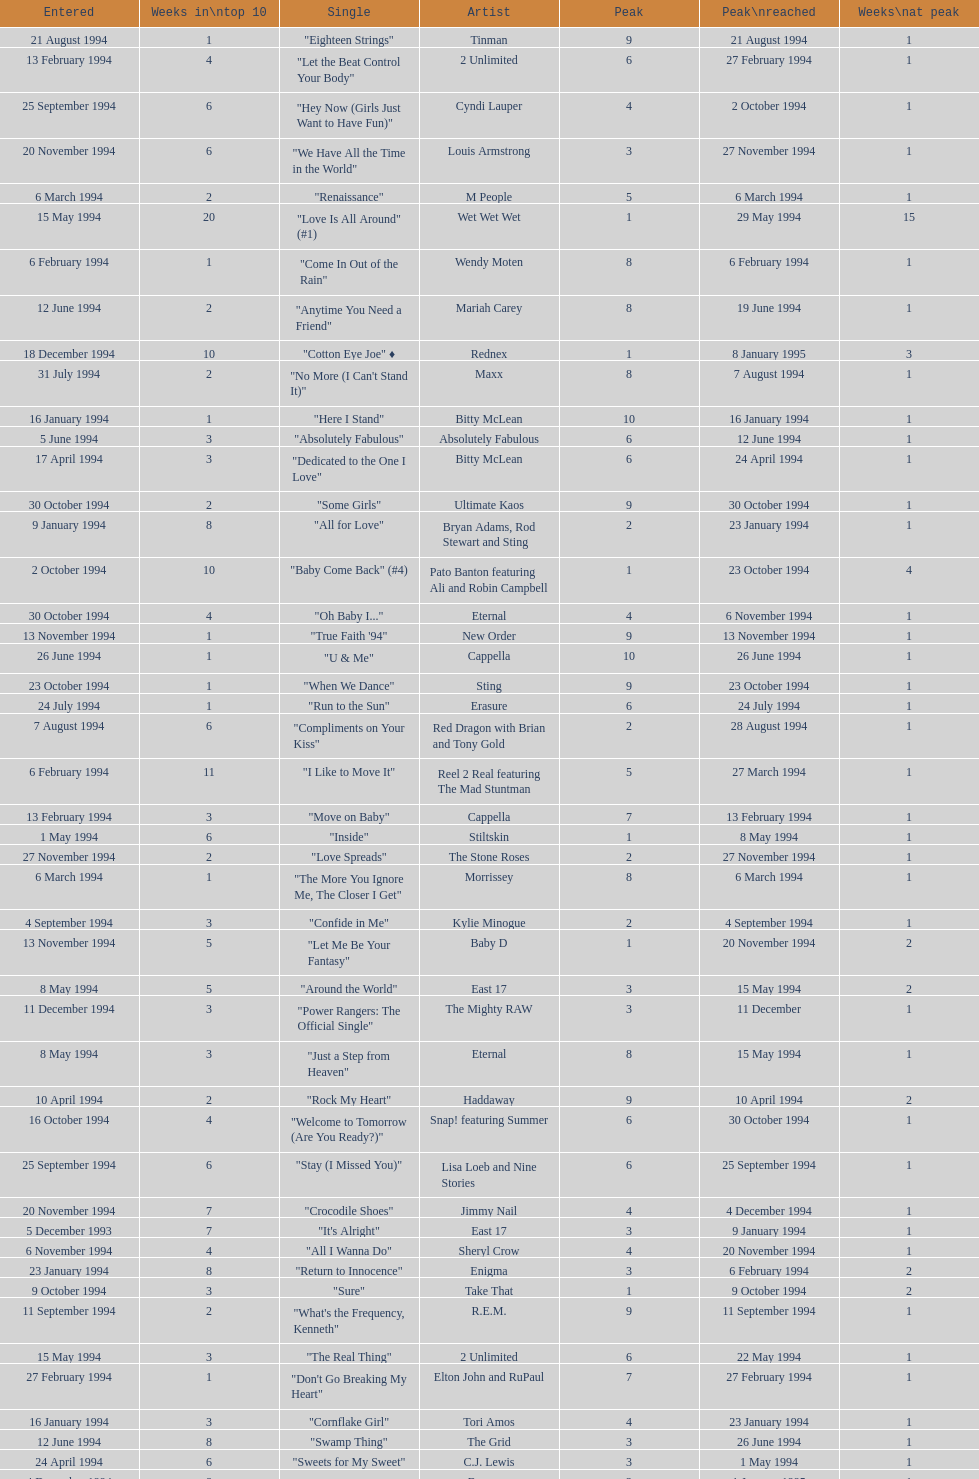Which single was the last one to be on the charts in 1993? "Come Baby Come". 